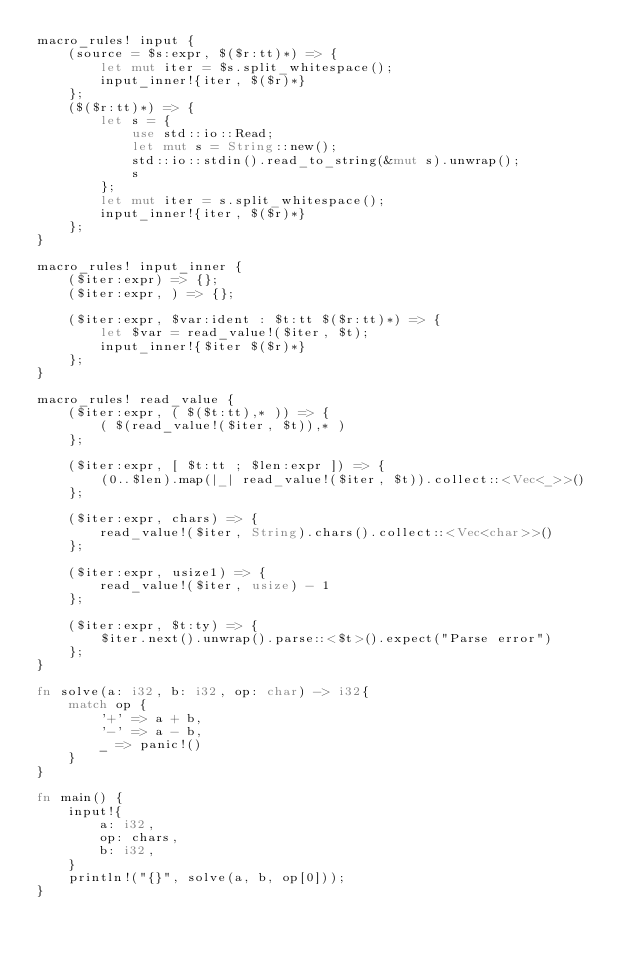Convert code to text. <code><loc_0><loc_0><loc_500><loc_500><_Rust_>macro_rules! input {
    (source = $s:expr, $($r:tt)*) => {
        let mut iter = $s.split_whitespace();
        input_inner!{iter, $($r)*}
    };
    ($($r:tt)*) => {
        let s = {
            use std::io::Read;
            let mut s = String::new();
            std::io::stdin().read_to_string(&mut s).unwrap();
            s
        };
        let mut iter = s.split_whitespace();
        input_inner!{iter, $($r)*}
    };
}

macro_rules! input_inner {
    ($iter:expr) => {};
    ($iter:expr, ) => {};

    ($iter:expr, $var:ident : $t:tt $($r:tt)*) => {
        let $var = read_value!($iter, $t);
        input_inner!{$iter $($r)*}
    };
}

macro_rules! read_value {
    ($iter:expr, ( $($t:tt),* )) => {
        ( $(read_value!($iter, $t)),* )
    };

    ($iter:expr, [ $t:tt ; $len:expr ]) => {
        (0..$len).map(|_| read_value!($iter, $t)).collect::<Vec<_>>()
    };

    ($iter:expr, chars) => {
        read_value!($iter, String).chars().collect::<Vec<char>>()
    };

    ($iter:expr, usize1) => {
        read_value!($iter, usize) - 1
    };

    ($iter:expr, $t:ty) => {
        $iter.next().unwrap().parse::<$t>().expect("Parse error")
    };
}

fn solve(a: i32, b: i32, op: char) -> i32{
    match op {
        '+' => a + b,
        '-' => a - b,
        _ => panic!()
    }
}

fn main() {
    input!{
        a: i32,
        op: chars,
        b: i32,
    }
    println!("{}", solve(a, b, op[0]));
}
</code> 